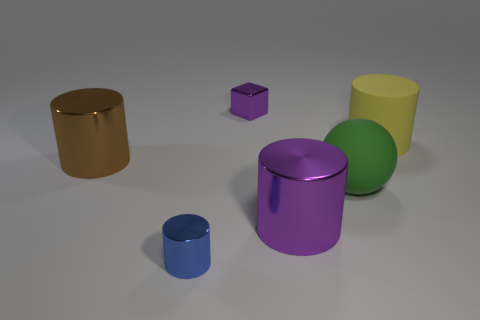Add 2 tiny purple cubes. How many objects exist? 8 Subtract all cylinders. How many objects are left? 2 Subtract all big green metallic things. Subtract all green spheres. How many objects are left? 5 Add 2 small metal blocks. How many small metal blocks are left? 3 Add 5 large brown metallic objects. How many large brown metallic objects exist? 6 Subtract 1 purple cubes. How many objects are left? 5 